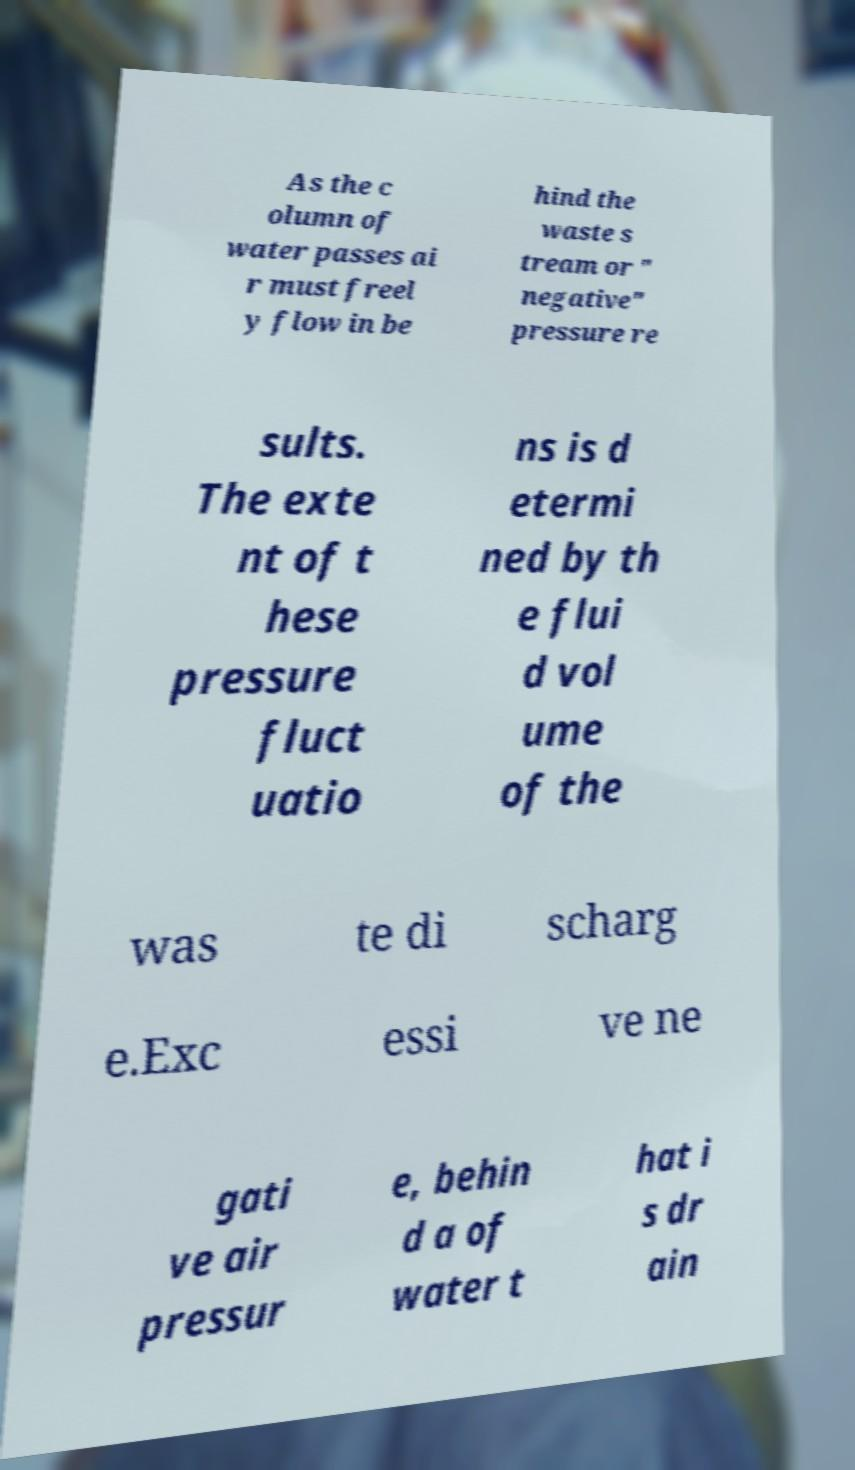Could you assist in decoding the text presented in this image and type it out clearly? As the c olumn of water passes ai r must freel y flow in be hind the waste s tream or " negative" pressure re sults. The exte nt of t hese pressure fluct uatio ns is d etermi ned by th e flui d vol ume of the was te di scharg e.Exc essi ve ne gati ve air pressur e, behin d a of water t hat i s dr ain 